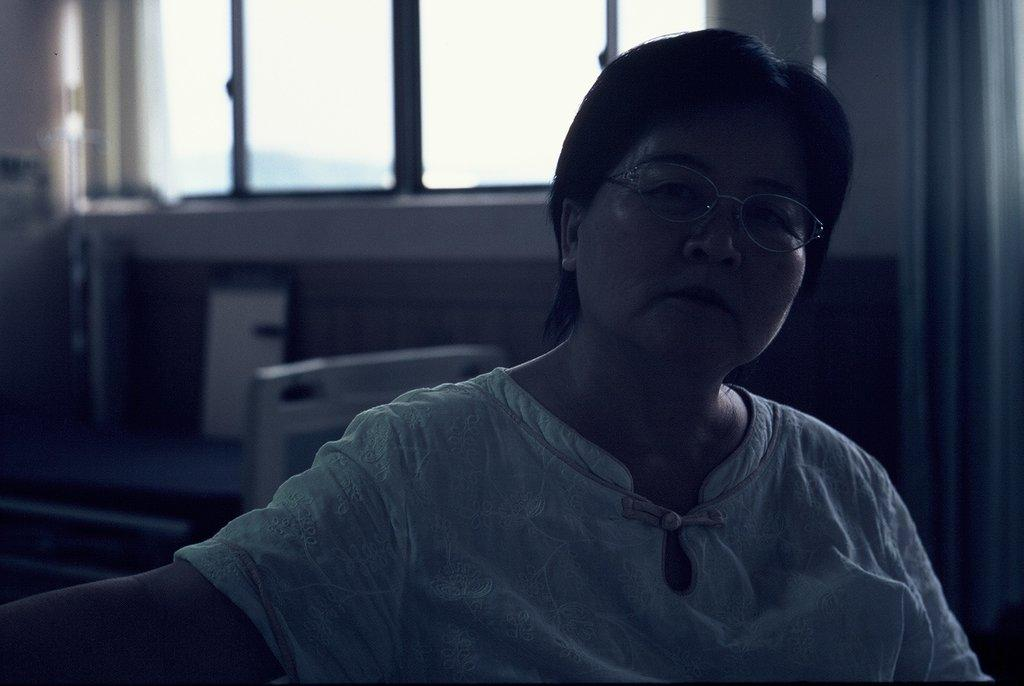What is the person in the image doing? The person is sitting on a chair in the image. What can be seen in the background of the image? There is a wall in the background of the image. What feature is present on the wall? The wall has a window. What is associated with the window? There is a curtain associated with the window. What object can be seen in the image that resembles a pad? There is an object that looks like a pad in the image. What type of honey is being produced by the machine in the image? There is no machine or honey present in the image. What type of food is the person eating in the image? The image does not show the person eating any food, so it cannot be determined from the image. 